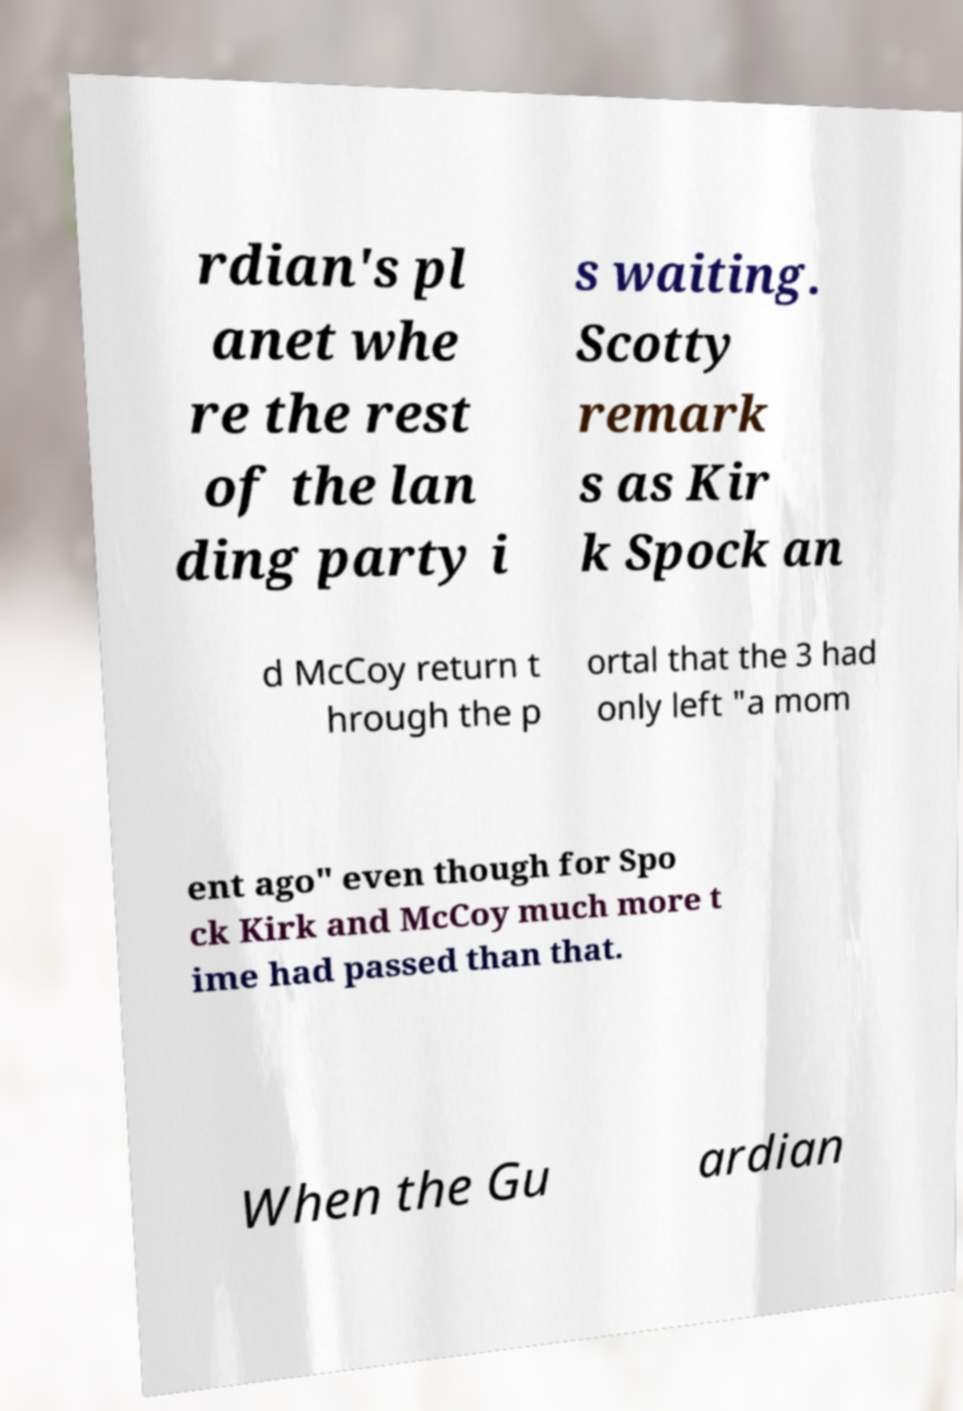For documentation purposes, I need the text within this image transcribed. Could you provide that? rdian's pl anet whe re the rest of the lan ding party i s waiting. Scotty remark s as Kir k Spock an d McCoy return t hrough the p ortal that the 3 had only left "a mom ent ago" even though for Spo ck Kirk and McCoy much more t ime had passed than that. When the Gu ardian 